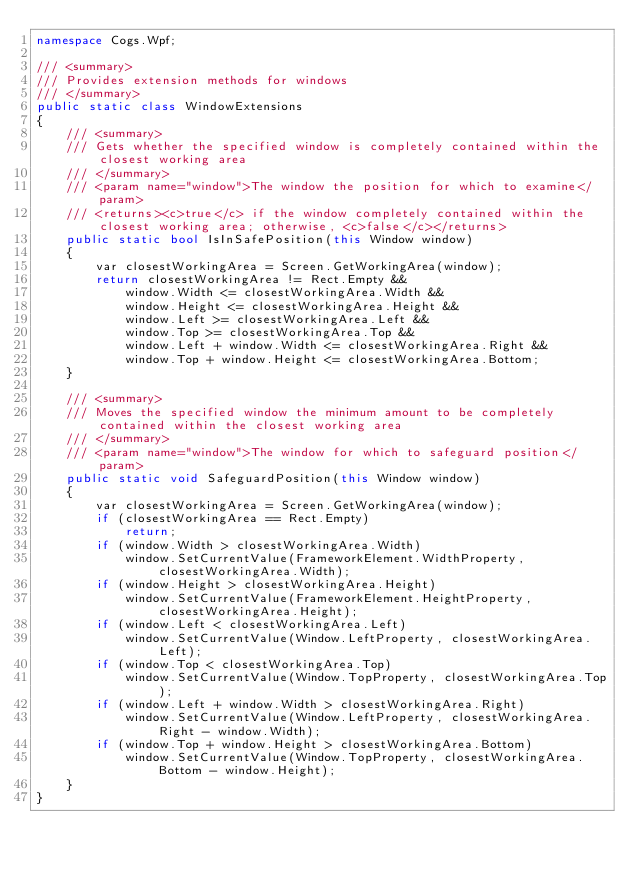<code> <loc_0><loc_0><loc_500><loc_500><_C#_>namespace Cogs.Wpf;

/// <summary>
/// Provides extension methods for windows
/// </summary>
public static class WindowExtensions
{
    /// <summary>
    /// Gets whether the specified window is completely contained within the closest working area
    /// </summary>
    /// <param name="window">The window the position for which to examine</param>
    /// <returns><c>true</c> if the window completely contained within the closest working area; otherwise, <c>false</c></returns>
    public static bool IsInSafePosition(this Window window)
    {
        var closestWorkingArea = Screen.GetWorkingArea(window);
        return closestWorkingArea != Rect.Empty &&
            window.Width <= closestWorkingArea.Width &&
            window.Height <= closestWorkingArea.Height &&
            window.Left >= closestWorkingArea.Left &&
            window.Top >= closestWorkingArea.Top &&
            window.Left + window.Width <= closestWorkingArea.Right &&
            window.Top + window.Height <= closestWorkingArea.Bottom;
    }

    /// <summary>
    /// Moves the specified window the minimum amount to be completely contained within the closest working area
    /// </summary>
    /// <param name="window">The window for which to safeguard position</param>
    public static void SafeguardPosition(this Window window)
    {
        var closestWorkingArea = Screen.GetWorkingArea(window);
        if (closestWorkingArea == Rect.Empty)
            return;
        if (window.Width > closestWorkingArea.Width)
            window.SetCurrentValue(FrameworkElement.WidthProperty, closestWorkingArea.Width);
        if (window.Height > closestWorkingArea.Height)
            window.SetCurrentValue(FrameworkElement.HeightProperty, closestWorkingArea.Height);
        if (window.Left < closestWorkingArea.Left)
            window.SetCurrentValue(Window.LeftProperty, closestWorkingArea.Left);
        if (window.Top < closestWorkingArea.Top)
            window.SetCurrentValue(Window.TopProperty, closestWorkingArea.Top);
        if (window.Left + window.Width > closestWorkingArea.Right)
            window.SetCurrentValue(Window.LeftProperty, closestWorkingArea.Right - window.Width);
        if (window.Top + window.Height > closestWorkingArea.Bottom)
            window.SetCurrentValue(Window.TopProperty, closestWorkingArea.Bottom - window.Height);
    }
}
</code> 